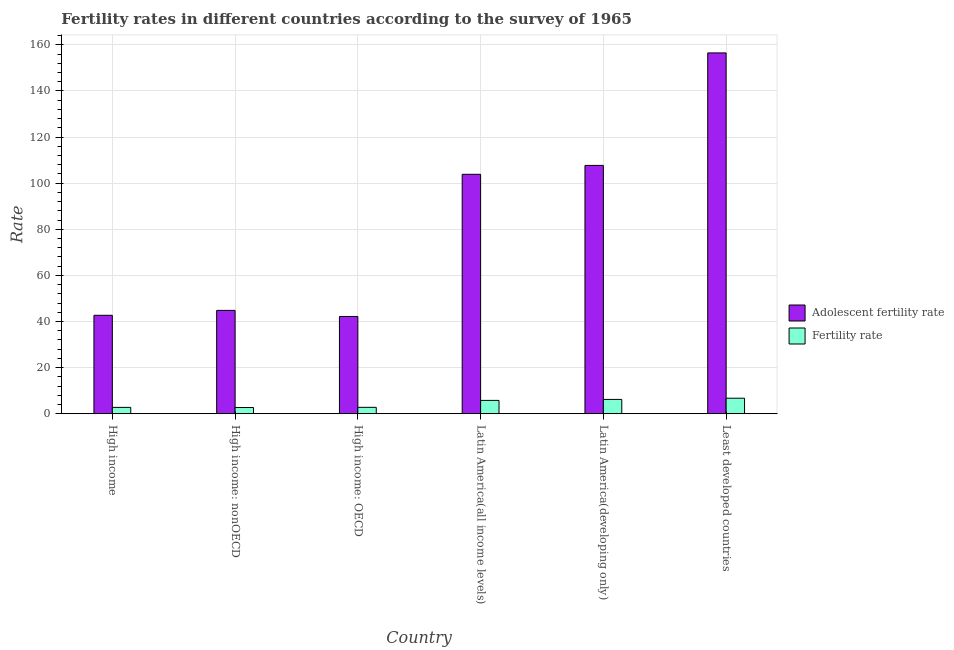How many groups of bars are there?
Offer a terse response. 6. Are the number of bars on each tick of the X-axis equal?
Provide a succinct answer. Yes. How many bars are there on the 2nd tick from the right?
Make the answer very short. 2. What is the label of the 2nd group of bars from the left?
Keep it short and to the point. High income: nonOECD. In how many cases, is the number of bars for a given country not equal to the number of legend labels?
Make the answer very short. 0. What is the fertility rate in High income: nonOECD?
Your answer should be very brief. 2.69. Across all countries, what is the maximum adolescent fertility rate?
Offer a terse response. 156.49. Across all countries, what is the minimum adolescent fertility rate?
Your answer should be compact. 42.18. In which country was the adolescent fertility rate maximum?
Make the answer very short. Least developed countries. In which country was the adolescent fertility rate minimum?
Ensure brevity in your answer.  High income: OECD. What is the total fertility rate in the graph?
Offer a very short reply. 26.96. What is the difference between the adolescent fertility rate in High income: OECD and that in Latin America(all income levels)?
Give a very brief answer. -61.66. What is the difference between the adolescent fertility rate in Latin America(all income levels) and the fertility rate in Least developed countries?
Keep it short and to the point. 97.11. What is the average adolescent fertility rate per country?
Offer a very short reply. 82.95. What is the difference between the fertility rate and adolescent fertility rate in Least developed countries?
Offer a very short reply. -149.75. In how many countries, is the adolescent fertility rate greater than 32 ?
Give a very brief answer. 6. What is the ratio of the fertility rate in High income: OECD to that in Latin America(developing only)?
Make the answer very short. 0.45. Is the difference between the fertility rate in High income: nonOECD and Latin America(all income levels) greater than the difference between the adolescent fertility rate in High income: nonOECD and Latin America(all income levels)?
Give a very brief answer. Yes. What is the difference between the highest and the second highest fertility rate?
Provide a short and direct response. 0.52. What is the difference between the highest and the lowest fertility rate?
Give a very brief answer. 4.04. What does the 2nd bar from the left in Latin America(all income levels) represents?
Ensure brevity in your answer.  Fertility rate. What does the 2nd bar from the right in High income: nonOECD represents?
Your answer should be very brief. Adolescent fertility rate. How many bars are there?
Offer a terse response. 12. How many countries are there in the graph?
Your answer should be compact. 6. Are the values on the major ticks of Y-axis written in scientific E-notation?
Your answer should be compact. No. Does the graph contain any zero values?
Keep it short and to the point. No. How are the legend labels stacked?
Offer a very short reply. Vertical. What is the title of the graph?
Provide a succinct answer. Fertility rates in different countries according to the survey of 1965. Does "Canada" appear as one of the legend labels in the graph?
Offer a terse response. No. What is the label or title of the X-axis?
Offer a terse response. Country. What is the label or title of the Y-axis?
Your answer should be very brief. Rate. What is the Rate in Adolescent fertility rate in High income?
Ensure brevity in your answer.  42.7. What is the Rate in Fertility rate in High income?
Keep it short and to the point. 2.76. What is the Rate in Adolescent fertility rate in High income: nonOECD?
Offer a terse response. 44.82. What is the Rate of Fertility rate in High income: nonOECD?
Your answer should be very brief. 2.69. What is the Rate of Adolescent fertility rate in High income: OECD?
Provide a short and direct response. 42.18. What is the Rate in Fertility rate in High income: OECD?
Offer a terse response. 2.78. What is the Rate of Adolescent fertility rate in Latin America(all income levels)?
Give a very brief answer. 103.84. What is the Rate in Fertility rate in Latin America(all income levels)?
Your response must be concise. 5.78. What is the Rate of Adolescent fertility rate in Latin America(developing only)?
Make the answer very short. 107.7. What is the Rate of Fertility rate in Latin America(developing only)?
Your answer should be very brief. 6.21. What is the Rate in Adolescent fertility rate in Least developed countries?
Offer a terse response. 156.49. What is the Rate of Fertility rate in Least developed countries?
Your answer should be very brief. 6.73. Across all countries, what is the maximum Rate in Adolescent fertility rate?
Ensure brevity in your answer.  156.49. Across all countries, what is the maximum Rate of Fertility rate?
Your answer should be very brief. 6.73. Across all countries, what is the minimum Rate of Adolescent fertility rate?
Keep it short and to the point. 42.18. Across all countries, what is the minimum Rate of Fertility rate?
Your answer should be compact. 2.69. What is the total Rate of Adolescent fertility rate in the graph?
Give a very brief answer. 497.72. What is the total Rate of Fertility rate in the graph?
Ensure brevity in your answer.  26.96. What is the difference between the Rate of Adolescent fertility rate in High income and that in High income: nonOECD?
Ensure brevity in your answer.  -2.13. What is the difference between the Rate in Fertility rate in High income and that in High income: nonOECD?
Your answer should be compact. 0.06. What is the difference between the Rate of Adolescent fertility rate in High income and that in High income: OECD?
Provide a succinct answer. 0.52. What is the difference between the Rate in Fertility rate in High income and that in High income: OECD?
Make the answer very short. -0.02. What is the difference between the Rate in Adolescent fertility rate in High income and that in Latin America(all income levels)?
Give a very brief answer. -61.15. What is the difference between the Rate of Fertility rate in High income and that in Latin America(all income levels)?
Make the answer very short. -3.02. What is the difference between the Rate of Adolescent fertility rate in High income and that in Latin America(developing only)?
Provide a short and direct response. -65. What is the difference between the Rate in Fertility rate in High income and that in Latin America(developing only)?
Offer a very short reply. -3.46. What is the difference between the Rate of Adolescent fertility rate in High income and that in Least developed countries?
Your answer should be very brief. -113.79. What is the difference between the Rate of Fertility rate in High income and that in Least developed countries?
Keep it short and to the point. -3.98. What is the difference between the Rate in Adolescent fertility rate in High income: nonOECD and that in High income: OECD?
Keep it short and to the point. 2.64. What is the difference between the Rate in Fertility rate in High income: nonOECD and that in High income: OECD?
Provide a succinct answer. -0.08. What is the difference between the Rate of Adolescent fertility rate in High income: nonOECD and that in Latin America(all income levels)?
Give a very brief answer. -59.02. What is the difference between the Rate in Fertility rate in High income: nonOECD and that in Latin America(all income levels)?
Provide a short and direct response. -3.09. What is the difference between the Rate in Adolescent fertility rate in High income: nonOECD and that in Latin America(developing only)?
Provide a short and direct response. -62.87. What is the difference between the Rate in Fertility rate in High income: nonOECD and that in Latin America(developing only)?
Your answer should be very brief. -3.52. What is the difference between the Rate in Adolescent fertility rate in High income: nonOECD and that in Least developed countries?
Offer a very short reply. -111.66. What is the difference between the Rate of Fertility rate in High income: nonOECD and that in Least developed countries?
Offer a very short reply. -4.04. What is the difference between the Rate of Adolescent fertility rate in High income: OECD and that in Latin America(all income levels)?
Offer a terse response. -61.66. What is the difference between the Rate in Fertility rate in High income: OECD and that in Latin America(all income levels)?
Make the answer very short. -3.01. What is the difference between the Rate in Adolescent fertility rate in High income: OECD and that in Latin America(developing only)?
Give a very brief answer. -65.52. What is the difference between the Rate in Fertility rate in High income: OECD and that in Latin America(developing only)?
Offer a terse response. -3.44. What is the difference between the Rate in Adolescent fertility rate in High income: OECD and that in Least developed countries?
Provide a short and direct response. -114.31. What is the difference between the Rate of Fertility rate in High income: OECD and that in Least developed countries?
Your answer should be compact. -3.96. What is the difference between the Rate of Adolescent fertility rate in Latin America(all income levels) and that in Latin America(developing only)?
Make the answer very short. -3.85. What is the difference between the Rate in Fertility rate in Latin America(all income levels) and that in Latin America(developing only)?
Offer a very short reply. -0.43. What is the difference between the Rate in Adolescent fertility rate in Latin America(all income levels) and that in Least developed countries?
Ensure brevity in your answer.  -52.64. What is the difference between the Rate in Fertility rate in Latin America(all income levels) and that in Least developed countries?
Your answer should be compact. -0.95. What is the difference between the Rate of Adolescent fertility rate in Latin America(developing only) and that in Least developed countries?
Your answer should be very brief. -48.79. What is the difference between the Rate of Fertility rate in Latin America(developing only) and that in Least developed countries?
Offer a terse response. -0.52. What is the difference between the Rate of Adolescent fertility rate in High income and the Rate of Fertility rate in High income: nonOECD?
Offer a terse response. 40. What is the difference between the Rate of Adolescent fertility rate in High income and the Rate of Fertility rate in High income: OECD?
Your response must be concise. 39.92. What is the difference between the Rate of Adolescent fertility rate in High income and the Rate of Fertility rate in Latin America(all income levels)?
Offer a very short reply. 36.91. What is the difference between the Rate of Adolescent fertility rate in High income and the Rate of Fertility rate in Latin America(developing only)?
Provide a succinct answer. 36.48. What is the difference between the Rate in Adolescent fertility rate in High income and the Rate in Fertility rate in Least developed countries?
Ensure brevity in your answer.  35.96. What is the difference between the Rate in Adolescent fertility rate in High income: nonOECD and the Rate in Fertility rate in High income: OECD?
Your response must be concise. 42.05. What is the difference between the Rate in Adolescent fertility rate in High income: nonOECD and the Rate in Fertility rate in Latin America(all income levels)?
Make the answer very short. 39.04. What is the difference between the Rate of Adolescent fertility rate in High income: nonOECD and the Rate of Fertility rate in Latin America(developing only)?
Offer a very short reply. 38.61. What is the difference between the Rate of Adolescent fertility rate in High income: nonOECD and the Rate of Fertility rate in Least developed countries?
Give a very brief answer. 38.09. What is the difference between the Rate of Adolescent fertility rate in High income: OECD and the Rate of Fertility rate in Latin America(all income levels)?
Your answer should be compact. 36.4. What is the difference between the Rate in Adolescent fertility rate in High income: OECD and the Rate in Fertility rate in Latin America(developing only)?
Your response must be concise. 35.97. What is the difference between the Rate in Adolescent fertility rate in High income: OECD and the Rate in Fertility rate in Least developed countries?
Give a very brief answer. 35.45. What is the difference between the Rate in Adolescent fertility rate in Latin America(all income levels) and the Rate in Fertility rate in Latin America(developing only)?
Provide a succinct answer. 97.63. What is the difference between the Rate of Adolescent fertility rate in Latin America(all income levels) and the Rate of Fertility rate in Least developed countries?
Provide a short and direct response. 97.11. What is the difference between the Rate of Adolescent fertility rate in Latin America(developing only) and the Rate of Fertility rate in Least developed countries?
Provide a short and direct response. 100.96. What is the average Rate of Adolescent fertility rate per country?
Ensure brevity in your answer.  82.95. What is the average Rate in Fertility rate per country?
Make the answer very short. 4.49. What is the difference between the Rate in Adolescent fertility rate and Rate in Fertility rate in High income?
Keep it short and to the point. 39.94. What is the difference between the Rate of Adolescent fertility rate and Rate of Fertility rate in High income: nonOECD?
Your answer should be very brief. 42.13. What is the difference between the Rate in Adolescent fertility rate and Rate in Fertility rate in High income: OECD?
Give a very brief answer. 39.4. What is the difference between the Rate in Adolescent fertility rate and Rate in Fertility rate in Latin America(all income levels)?
Provide a short and direct response. 98.06. What is the difference between the Rate of Adolescent fertility rate and Rate of Fertility rate in Latin America(developing only)?
Your answer should be very brief. 101.48. What is the difference between the Rate of Adolescent fertility rate and Rate of Fertility rate in Least developed countries?
Offer a very short reply. 149.75. What is the ratio of the Rate of Adolescent fertility rate in High income to that in High income: nonOECD?
Provide a succinct answer. 0.95. What is the ratio of the Rate in Fertility rate in High income to that in High income: nonOECD?
Provide a succinct answer. 1.02. What is the ratio of the Rate of Adolescent fertility rate in High income to that in High income: OECD?
Offer a terse response. 1.01. What is the ratio of the Rate of Adolescent fertility rate in High income to that in Latin America(all income levels)?
Make the answer very short. 0.41. What is the ratio of the Rate in Fertility rate in High income to that in Latin America(all income levels)?
Provide a short and direct response. 0.48. What is the ratio of the Rate in Adolescent fertility rate in High income to that in Latin America(developing only)?
Keep it short and to the point. 0.4. What is the ratio of the Rate in Fertility rate in High income to that in Latin America(developing only)?
Give a very brief answer. 0.44. What is the ratio of the Rate in Adolescent fertility rate in High income to that in Least developed countries?
Offer a terse response. 0.27. What is the ratio of the Rate in Fertility rate in High income to that in Least developed countries?
Offer a terse response. 0.41. What is the ratio of the Rate of Adolescent fertility rate in High income: nonOECD to that in High income: OECD?
Offer a terse response. 1.06. What is the ratio of the Rate in Fertility rate in High income: nonOECD to that in High income: OECD?
Ensure brevity in your answer.  0.97. What is the ratio of the Rate of Adolescent fertility rate in High income: nonOECD to that in Latin America(all income levels)?
Provide a succinct answer. 0.43. What is the ratio of the Rate of Fertility rate in High income: nonOECD to that in Latin America(all income levels)?
Make the answer very short. 0.47. What is the ratio of the Rate of Adolescent fertility rate in High income: nonOECD to that in Latin America(developing only)?
Your answer should be compact. 0.42. What is the ratio of the Rate of Fertility rate in High income: nonOECD to that in Latin America(developing only)?
Ensure brevity in your answer.  0.43. What is the ratio of the Rate in Adolescent fertility rate in High income: nonOECD to that in Least developed countries?
Provide a short and direct response. 0.29. What is the ratio of the Rate in Fertility rate in High income: nonOECD to that in Least developed countries?
Your answer should be very brief. 0.4. What is the ratio of the Rate of Adolescent fertility rate in High income: OECD to that in Latin America(all income levels)?
Provide a succinct answer. 0.41. What is the ratio of the Rate of Fertility rate in High income: OECD to that in Latin America(all income levels)?
Your answer should be very brief. 0.48. What is the ratio of the Rate in Adolescent fertility rate in High income: OECD to that in Latin America(developing only)?
Make the answer very short. 0.39. What is the ratio of the Rate in Fertility rate in High income: OECD to that in Latin America(developing only)?
Provide a short and direct response. 0.45. What is the ratio of the Rate in Adolescent fertility rate in High income: OECD to that in Least developed countries?
Provide a short and direct response. 0.27. What is the ratio of the Rate in Fertility rate in High income: OECD to that in Least developed countries?
Your answer should be very brief. 0.41. What is the ratio of the Rate of Adolescent fertility rate in Latin America(all income levels) to that in Latin America(developing only)?
Provide a succinct answer. 0.96. What is the ratio of the Rate in Fertility rate in Latin America(all income levels) to that in Latin America(developing only)?
Keep it short and to the point. 0.93. What is the ratio of the Rate of Adolescent fertility rate in Latin America(all income levels) to that in Least developed countries?
Make the answer very short. 0.66. What is the ratio of the Rate in Fertility rate in Latin America(all income levels) to that in Least developed countries?
Offer a terse response. 0.86. What is the ratio of the Rate in Adolescent fertility rate in Latin America(developing only) to that in Least developed countries?
Offer a very short reply. 0.69. What is the ratio of the Rate in Fertility rate in Latin America(developing only) to that in Least developed countries?
Provide a short and direct response. 0.92. What is the difference between the highest and the second highest Rate in Adolescent fertility rate?
Offer a very short reply. 48.79. What is the difference between the highest and the second highest Rate in Fertility rate?
Offer a very short reply. 0.52. What is the difference between the highest and the lowest Rate of Adolescent fertility rate?
Offer a terse response. 114.31. What is the difference between the highest and the lowest Rate of Fertility rate?
Your answer should be compact. 4.04. 